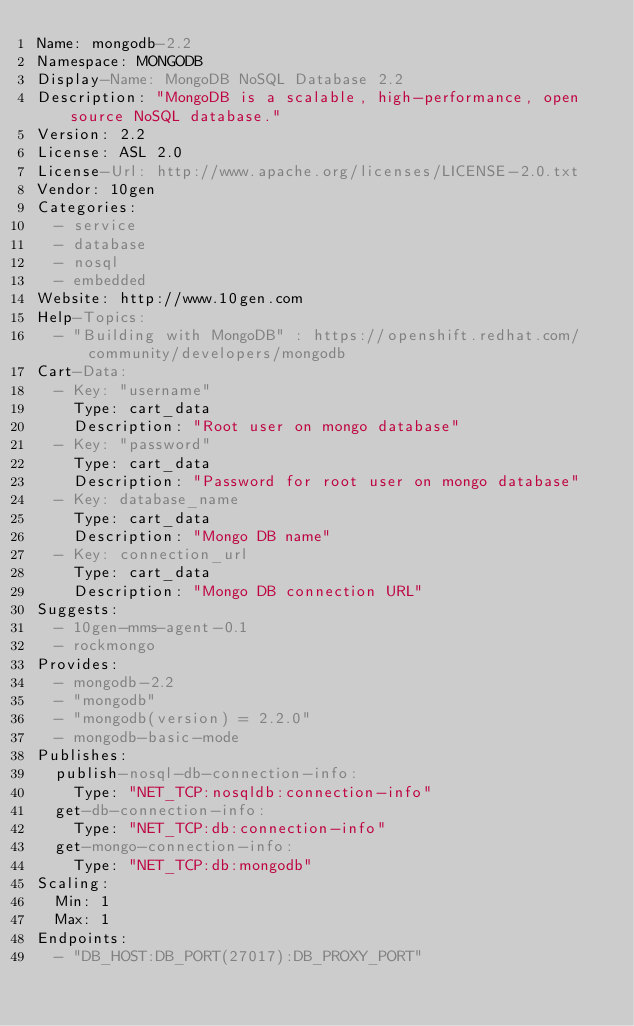Convert code to text. <code><loc_0><loc_0><loc_500><loc_500><_YAML_>Name: mongodb-2.2
Namespace: MONGODB
Display-Name: MongoDB NoSQL Database 2.2
Description: "MongoDB is a scalable, high-performance, open source NoSQL database."
Version: 2.2
License: ASL 2.0
License-Url: http://www.apache.org/licenses/LICENSE-2.0.txt
Vendor: 10gen
Categories:
  - service
  - database
  - nosql
  - embedded
Website: http://www.10gen.com
Help-Topics:
  - "Building with MongoDB" : https://openshift.redhat.com/community/developers/mongodb
Cart-Data:
  - Key: "username"
    Type: cart_data
    Description: "Root user on mongo database"
  - Key: "password"
    Type: cart_data
    Description: "Password for root user on mongo database"
  - Key: database_name
    Type: cart_data
    Description: "Mongo DB name"
  - Key: connection_url
    Type: cart_data
    Description: "Mongo DB connection URL"
Suggests:
  - 10gen-mms-agent-0.1
  - rockmongo
Provides:
  - mongodb-2.2
  - "mongodb"
  - "mongodb(version) = 2.2.0"
  - mongodb-basic-mode
Publishes:
  publish-nosql-db-connection-info:
    Type: "NET_TCP:nosqldb:connection-info"
  get-db-connection-info:
    Type: "NET_TCP:db:connection-info"
  get-mongo-connection-info:
    Type: "NET_TCP:db:mongodb"
Scaling:
  Min: 1
  Max: 1
Endpoints:
  - "DB_HOST:DB_PORT(27017):DB_PROXY_PORT"
</code> 